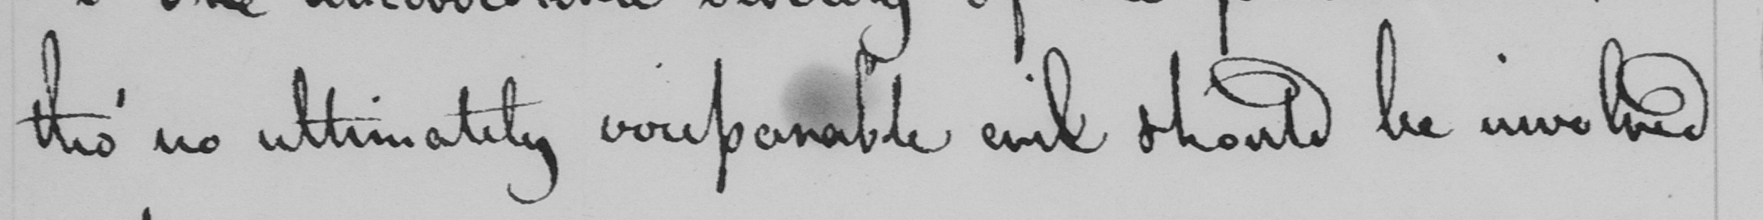Transcribe the text shown in this historical manuscript line. tho '  no ultimately irriparable evil should be involved 